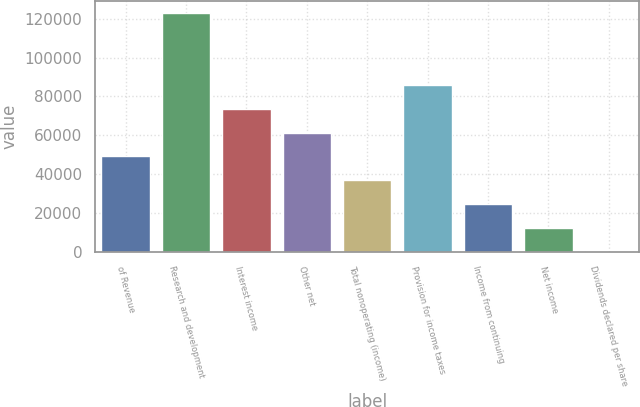Convert chart. <chart><loc_0><loc_0><loc_500><loc_500><bar_chart><fcel>of Revenue<fcel>Research and development<fcel>Interest income<fcel>Other net<fcel>Total nonoperating (income)<fcel>Provision for income taxes<fcel>Income from continuing<fcel>Net income<fcel>Dividends declared per share<nl><fcel>49112.1<fcel>122780<fcel>73668.1<fcel>61390.1<fcel>36834.1<fcel>85946.1<fcel>24556.2<fcel>12278.2<fcel>0.2<nl></chart> 